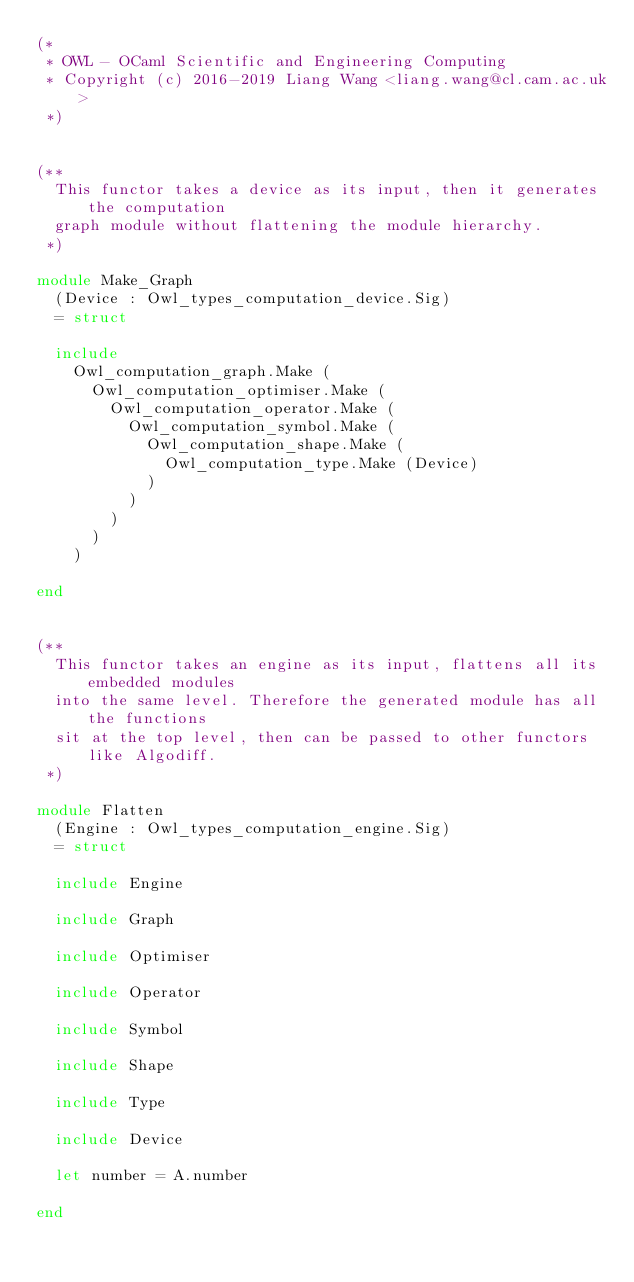Convert code to text. <code><loc_0><loc_0><loc_500><loc_500><_OCaml_>(*
 * OWL - OCaml Scientific and Engineering Computing
 * Copyright (c) 2016-2019 Liang Wang <liang.wang@cl.cam.ac.uk>
 *)


(**
  This functor takes a device as its input, then it generates the computation
  graph module without flattening the module hierarchy.
 *)

module Make_Graph
  (Device : Owl_types_computation_device.Sig)
  = struct

  include
    Owl_computation_graph.Make (
      Owl_computation_optimiser.Make (
        Owl_computation_operator.Make (
          Owl_computation_symbol.Make (
            Owl_computation_shape.Make (
              Owl_computation_type.Make (Device)
            )
          )
        )
      )
    )

end


(**
  This functor takes an engine as its input, flattens all its embedded modules
  into the same level. Therefore the generated module has all the functions
  sit at the top level, then can be passed to other functors like Algodiff.
 *)

module Flatten
  (Engine : Owl_types_computation_engine.Sig)
  = struct

  include Engine

  include Graph

  include Optimiser

  include Operator

  include Symbol

  include Shape

  include Type

  include Device

  let number = A.number

end
</code> 